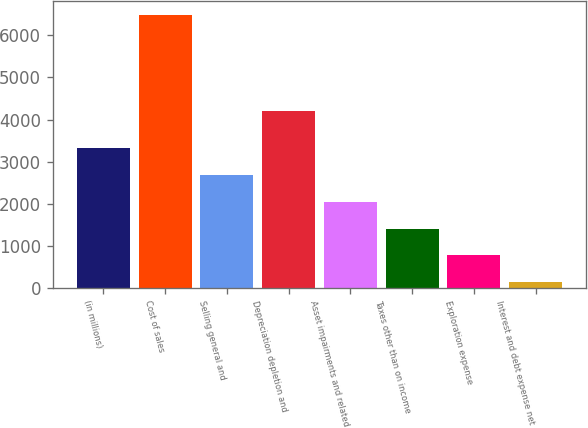<chart> <loc_0><loc_0><loc_500><loc_500><bar_chart><fcel>(in millions)<fcel>Cost of sales<fcel>Selling general and<fcel>Depreciation depletion and<fcel>Asset impairments and related<fcel>Taxes other than on income<fcel>Exploration expense<fcel>Interest and debt expense net<nl><fcel>3314.5<fcel>6497<fcel>2678<fcel>4203<fcel>2041.5<fcel>1405<fcel>768.5<fcel>132<nl></chart> 